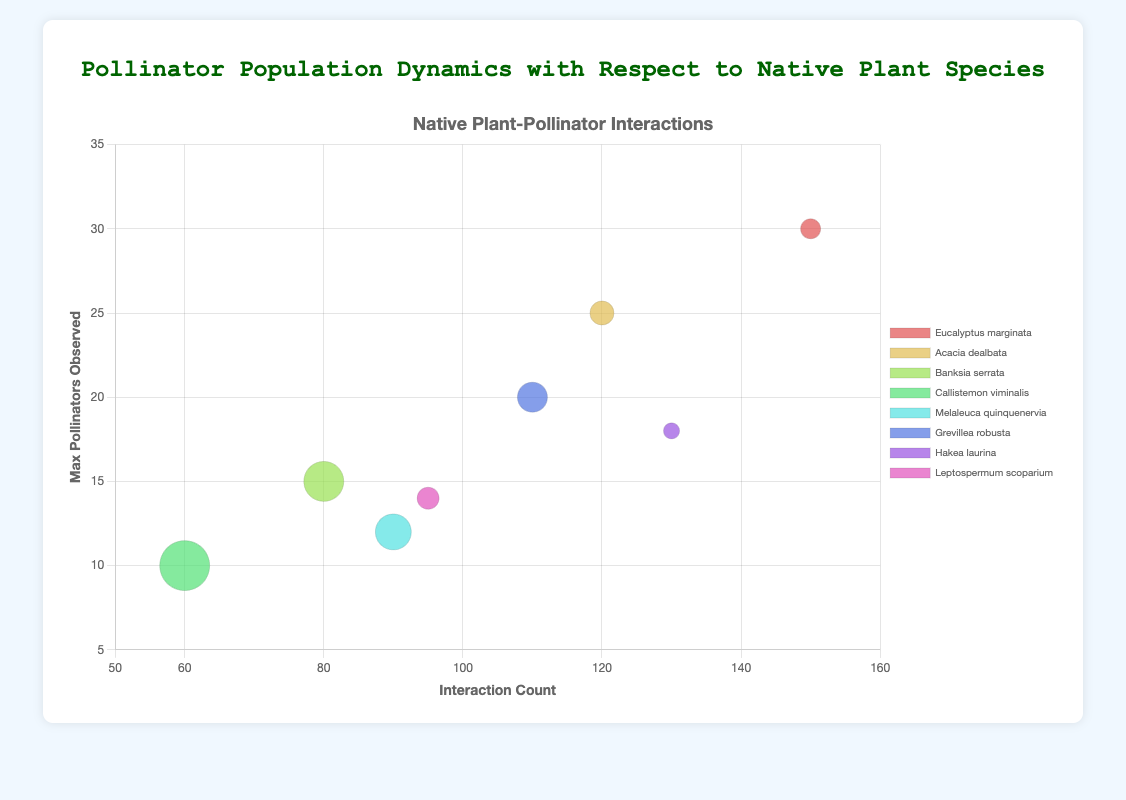Which plant species has the highest interaction count? The plant species with the highest interaction count can be determined by looking at the x-axis and finding the bubble that is positioned farthest to the right. In this case, "Eucalyptus marginata" has the highest interaction count of 150.
Answer: Eucalyptus marginata What is the average max number of pollinators observed for "Grevillea robusta" and "Melaleuca quinquenervia"? To compute the average, sum the max pollinators observed for both species and divide by 2. "Grevillea robusta" has 20 and "Melaleuca quinquenervia" has 12. (20 + 12) / 2 = 16
Answer: 16 Which pollinator species interacting with "Banksia serrata" has the largest average weight? To find this, check the size of the bubbles corresponding to "Banksia serrata". "Bombus terrestris" interacting with "Banksia serrata" has the largest average weight which is 0.2g.
Answer: Bombus terrestris Which plant species has the smallest bubble size? The bubble size represents the average pollinator weight. By comparing the sizes of the bubbles, it's evident that "Hakea laurina" has the smallest bubble representing an average pollinator weight of 0.08g.
Answer: Hakea laurina How many plant species have a max pollinator count greater than 15? To answer this, count the bubbles which are positioned above the y-axis value of 15. The plant species are "Eucalyptus marginata", "Acacia dealbata", "Grevillea robusta", and "Hakea laurina", making a total of 4.
Answer: 4 Which two plant species have a similar interaction count of around 120? Look at the x-axis and find the bubbles near the value of 120. "Acacia dealbata" and "Grevillea robusta" both have interaction counts close to 120, specifically 120 and 110 respectively.
Answer: Acacia dealbata and Grevillea robusta What is the color of the bubble representing "Callistemon viminalis"? The color for each bubble is represented uniquely for each plant species and can be identified visually. The bubble for "Callistemon viminalis" appears in a certain shade which distinctly identifies it among others.
Answer: Assigned color Compare the max number of pollinators observed for "Acacia dealbata" and "Leptospermum scoparium". Which is higher? Look at the y-axis values of the bubbles for these two plant species. "Acacia dealbata" has a max pollinator count of 25, while "Leptospermum scoparium" has 14. Thus, "Acacia dealbata" has a higher count.
Answer: Acacia dealbata What is the title of the chart? The title of the chart is prominently displayed at the top of the figure. It is "Pollinator Population Dynamics with Respect to Native Plant Species".
Answer: Pollinator Population Dynamics with Respect to Native Plant Species 